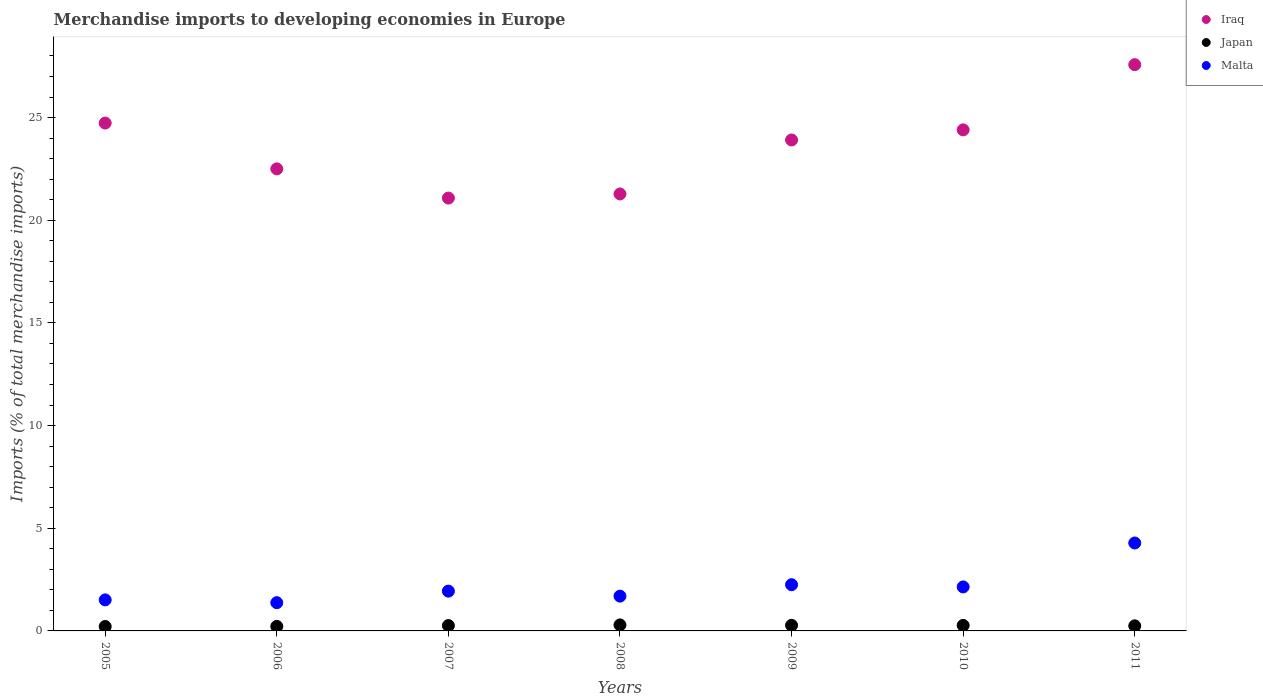How many different coloured dotlines are there?
Your answer should be compact. 3. What is the percentage total merchandise imports in Malta in 2009?
Your answer should be compact. 2.25. Across all years, what is the maximum percentage total merchandise imports in Malta?
Provide a short and direct response. 4.28. Across all years, what is the minimum percentage total merchandise imports in Malta?
Make the answer very short. 1.38. In which year was the percentage total merchandise imports in Japan maximum?
Your answer should be compact. 2008. In which year was the percentage total merchandise imports in Japan minimum?
Offer a very short reply. 2005. What is the total percentage total merchandise imports in Japan in the graph?
Your answer should be compact. 1.78. What is the difference between the percentage total merchandise imports in Malta in 2007 and that in 2011?
Provide a succinct answer. -2.34. What is the difference between the percentage total merchandise imports in Japan in 2006 and the percentage total merchandise imports in Iraq in 2009?
Keep it short and to the point. -23.69. What is the average percentage total merchandise imports in Japan per year?
Offer a terse response. 0.25. In the year 2011, what is the difference between the percentage total merchandise imports in Japan and percentage total merchandise imports in Iraq?
Keep it short and to the point. -27.33. What is the ratio of the percentage total merchandise imports in Iraq in 2006 to that in 2008?
Your answer should be compact. 1.06. What is the difference between the highest and the second highest percentage total merchandise imports in Malta?
Give a very brief answer. 2.03. What is the difference between the highest and the lowest percentage total merchandise imports in Japan?
Offer a terse response. 0.08. In how many years, is the percentage total merchandise imports in Malta greater than the average percentage total merchandise imports in Malta taken over all years?
Provide a short and direct response. 2. Is the percentage total merchandise imports in Iraq strictly greater than the percentage total merchandise imports in Japan over the years?
Offer a very short reply. Yes. Is the percentage total merchandise imports in Malta strictly less than the percentage total merchandise imports in Japan over the years?
Your response must be concise. No. How many years are there in the graph?
Ensure brevity in your answer.  7. What is the difference between two consecutive major ticks on the Y-axis?
Make the answer very short. 5. Are the values on the major ticks of Y-axis written in scientific E-notation?
Keep it short and to the point. No. Does the graph contain any zero values?
Your answer should be compact. No. Does the graph contain grids?
Keep it short and to the point. No. Where does the legend appear in the graph?
Your response must be concise. Top right. How many legend labels are there?
Provide a succinct answer. 3. How are the legend labels stacked?
Keep it short and to the point. Vertical. What is the title of the graph?
Provide a short and direct response. Merchandise imports to developing economies in Europe. Does "Latin America(developing only)" appear as one of the legend labels in the graph?
Offer a terse response. No. What is the label or title of the Y-axis?
Provide a succinct answer. Imports (% of total merchandise imports). What is the Imports (% of total merchandise imports) in Iraq in 2005?
Provide a succinct answer. 24.73. What is the Imports (% of total merchandise imports) of Japan in 2005?
Your answer should be very brief. 0.22. What is the Imports (% of total merchandise imports) in Malta in 2005?
Keep it short and to the point. 1.51. What is the Imports (% of total merchandise imports) of Iraq in 2006?
Keep it short and to the point. 22.5. What is the Imports (% of total merchandise imports) of Japan in 2006?
Ensure brevity in your answer.  0.22. What is the Imports (% of total merchandise imports) in Malta in 2006?
Ensure brevity in your answer.  1.38. What is the Imports (% of total merchandise imports) of Iraq in 2007?
Give a very brief answer. 21.08. What is the Imports (% of total merchandise imports) in Japan in 2007?
Give a very brief answer. 0.26. What is the Imports (% of total merchandise imports) in Malta in 2007?
Keep it short and to the point. 1.94. What is the Imports (% of total merchandise imports) in Iraq in 2008?
Ensure brevity in your answer.  21.28. What is the Imports (% of total merchandise imports) in Japan in 2008?
Offer a very short reply. 0.29. What is the Imports (% of total merchandise imports) in Malta in 2008?
Provide a succinct answer. 1.69. What is the Imports (% of total merchandise imports) in Iraq in 2009?
Make the answer very short. 23.91. What is the Imports (% of total merchandise imports) in Japan in 2009?
Your answer should be compact. 0.27. What is the Imports (% of total merchandise imports) in Malta in 2009?
Ensure brevity in your answer.  2.25. What is the Imports (% of total merchandise imports) in Iraq in 2010?
Give a very brief answer. 24.4. What is the Imports (% of total merchandise imports) in Japan in 2010?
Make the answer very short. 0.27. What is the Imports (% of total merchandise imports) in Malta in 2010?
Offer a very short reply. 2.14. What is the Imports (% of total merchandise imports) in Iraq in 2011?
Provide a short and direct response. 27.57. What is the Imports (% of total merchandise imports) in Japan in 2011?
Offer a very short reply. 0.25. What is the Imports (% of total merchandise imports) in Malta in 2011?
Offer a terse response. 4.28. Across all years, what is the maximum Imports (% of total merchandise imports) of Iraq?
Keep it short and to the point. 27.57. Across all years, what is the maximum Imports (% of total merchandise imports) in Japan?
Your response must be concise. 0.29. Across all years, what is the maximum Imports (% of total merchandise imports) of Malta?
Your response must be concise. 4.28. Across all years, what is the minimum Imports (% of total merchandise imports) of Iraq?
Ensure brevity in your answer.  21.08. Across all years, what is the minimum Imports (% of total merchandise imports) of Japan?
Give a very brief answer. 0.22. Across all years, what is the minimum Imports (% of total merchandise imports) in Malta?
Give a very brief answer. 1.38. What is the total Imports (% of total merchandise imports) of Iraq in the graph?
Your answer should be very brief. 165.47. What is the total Imports (% of total merchandise imports) of Japan in the graph?
Offer a terse response. 1.78. What is the total Imports (% of total merchandise imports) of Malta in the graph?
Your answer should be very brief. 15.19. What is the difference between the Imports (% of total merchandise imports) of Iraq in 2005 and that in 2006?
Make the answer very short. 2.23. What is the difference between the Imports (% of total merchandise imports) in Japan in 2005 and that in 2006?
Your answer should be compact. -0. What is the difference between the Imports (% of total merchandise imports) of Malta in 2005 and that in 2006?
Offer a very short reply. 0.14. What is the difference between the Imports (% of total merchandise imports) in Iraq in 2005 and that in 2007?
Your answer should be compact. 3.65. What is the difference between the Imports (% of total merchandise imports) in Japan in 2005 and that in 2007?
Your response must be concise. -0.05. What is the difference between the Imports (% of total merchandise imports) in Malta in 2005 and that in 2007?
Keep it short and to the point. -0.43. What is the difference between the Imports (% of total merchandise imports) of Iraq in 2005 and that in 2008?
Provide a succinct answer. 3.45. What is the difference between the Imports (% of total merchandise imports) of Japan in 2005 and that in 2008?
Provide a short and direct response. -0.08. What is the difference between the Imports (% of total merchandise imports) in Malta in 2005 and that in 2008?
Give a very brief answer. -0.18. What is the difference between the Imports (% of total merchandise imports) of Iraq in 2005 and that in 2009?
Your response must be concise. 0.82. What is the difference between the Imports (% of total merchandise imports) in Japan in 2005 and that in 2009?
Provide a short and direct response. -0.06. What is the difference between the Imports (% of total merchandise imports) of Malta in 2005 and that in 2009?
Make the answer very short. -0.74. What is the difference between the Imports (% of total merchandise imports) of Iraq in 2005 and that in 2010?
Your answer should be very brief. 0.33. What is the difference between the Imports (% of total merchandise imports) of Japan in 2005 and that in 2010?
Ensure brevity in your answer.  -0.05. What is the difference between the Imports (% of total merchandise imports) in Malta in 2005 and that in 2010?
Make the answer very short. -0.63. What is the difference between the Imports (% of total merchandise imports) of Iraq in 2005 and that in 2011?
Make the answer very short. -2.84. What is the difference between the Imports (% of total merchandise imports) in Japan in 2005 and that in 2011?
Give a very brief answer. -0.03. What is the difference between the Imports (% of total merchandise imports) in Malta in 2005 and that in 2011?
Your answer should be compact. -2.77. What is the difference between the Imports (% of total merchandise imports) in Iraq in 2006 and that in 2007?
Offer a terse response. 1.42. What is the difference between the Imports (% of total merchandise imports) of Japan in 2006 and that in 2007?
Keep it short and to the point. -0.04. What is the difference between the Imports (% of total merchandise imports) of Malta in 2006 and that in 2007?
Give a very brief answer. -0.56. What is the difference between the Imports (% of total merchandise imports) in Iraq in 2006 and that in 2008?
Provide a succinct answer. 1.22. What is the difference between the Imports (% of total merchandise imports) of Japan in 2006 and that in 2008?
Keep it short and to the point. -0.07. What is the difference between the Imports (% of total merchandise imports) of Malta in 2006 and that in 2008?
Your answer should be compact. -0.32. What is the difference between the Imports (% of total merchandise imports) of Iraq in 2006 and that in 2009?
Keep it short and to the point. -1.41. What is the difference between the Imports (% of total merchandise imports) in Japan in 2006 and that in 2009?
Offer a terse response. -0.05. What is the difference between the Imports (% of total merchandise imports) of Malta in 2006 and that in 2009?
Offer a terse response. -0.88. What is the difference between the Imports (% of total merchandise imports) in Iraq in 2006 and that in 2010?
Provide a succinct answer. -1.9. What is the difference between the Imports (% of total merchandise imports) in Japan in 2006 and that in 2010?
Your answer should be compact. -0.05. What is the difference between the Imports (% of total merchandise imports) of Malta in 2006 and that in 2010?
Give a very brief answer. -0.77. What is the difference between the Imports (% of total merchandise imports) in Iraq in 2006 and that in 2011?
Provide a succinct answer. -5.07. What is the difference between the Imports (% of total merchandise imports) of Japan in 2006 and that in 2011?
Keep it short and to the point. -0.03. What is the difference between the Imports (% of total merchandise imports) of Malta in 2006 and that in 2011?
Your response must be concise. -2.91. What is the difference between the Imports (% of total merchandise imports) in Iraq in 2007 and that in 2008?
Your answer should be compact. -0.2. What is the difference between the Imports (% of total merchandise imports) of Japan in 2007 and that in 2008?
Make the answer very short. -0.03. What is the difference between the Imports (% of total merchandise imports) of Malta in 2007 and that in 2008?
Provide a succinct answer. 0.24. What is the difference between the Imports (% of total merchandise imports) in Iraq in 2007 and that in 2009?
Make the answer very short. -2.83. What is the difference between the Imports (% of total merchandise imports) of Japan in 2007 and that in 2009?
Give a very brief answer. -0.01. What is the difference between the Imports (% of total merchandise imports) in Malta in 2007 and that in 2009?
Make the answer very short. -0.31. What is the difference between the Imports (% of total merchandise imports) in Iraq in 2007 and that in 2010?
Offer a terse response. -3.32. What is the difference between the Imports (% of total merchandise imports) in Japan in 2007 and that in 2010?
Ensure brevity in your answer.  -0.01. What is the difference between the Imports (% of total merchandise imports) in Malta in 2007 and that in 2010?
Offer a very short reply. -0.21. What is the difference between the Imports (% of total merchandise imports) of Iraq in 2007 and that in 2011?
Give a very brief answer. -6.5. What is the difference between the Imports (% of total merchandise imports) of Japan in 2007 and that in 2011?
Give a very brief answer. 0.01. What is the difference between the Imports (% of total merchandise imports) of Malta in 2007 and that in 2011?
Keep it short and to the point. -2.34. What is the difference between the Imports (% of total merchandise imports) of Iraq in 2008 and that in 2009?
Provide a succinct answer. -2.63. What is the difference between the Imports (% of total merchandise imports) of Japan in 2008 and that in 2009?
Ensure brevity in your answer.  0.02. What is the difference between the Imports (% of total merchandise imports) in Malta in 2008 and that in 2009?
Keep it short and to the point. -0.56. What is the difference between the Imports (% of total merchandise imports) of Iraq in 2008 and that in 2010?
Your response must be concise. -3.12. What is the difference between the Imports (% of total merchandise imports) of Japan in 2008 and that in 2010?
Keep it short and to the point. 0.03. What is the difference between the Imports (% of total merchandise imports) in Malta in 2008 and that in 2010?
Your answer should be very brief. -0.45. What is the difference between the Imports (% of total merchandise imports) in Iraq in 2008 and that in 2011?
Offer a terse response. -6.3. What is the difference between the Imports (% of total merchandise imports) in Japan in 2008 and that in 2011?
Give a very brief answer. 0.04. What is the difference between the Imports (% of total merchandise imports) of Malta in 2008 and that in 2011?
Give a very brief answer. -2.59. What is the difference between the Imports (% of total merchandise imports) in Iraq in 2009 and that in 2010?
Give a very brief answer. -0.49. What is the difference between the Imports (% of total merchandise imports) of Japan in 2009 and that in 2010?
Provide a succinct answer. 0.01. What is the difference between the Imports (% of total merchandise imports) in Malta in 2009 and that in 2010?
Your answer should be very brief. 0.11. What is the difference between the Imports (% of total merchandise imports) of Iraq in 2009 and that in 2011?
Offer a very short reply. -3.67. What is the difference between the Imports (% of total merchandise imports) in Japan in 2009 and that in 2011?
Your answer should be compact. 0.02. What is the difference between the Imports (% of total merchandise imports) in Malta in 2009 and that in 2011?
Make the answer very short. -2.03. What is the difference between the Imports (% of total merchandise imports) in Iraq in 2010 and that in 2011?
Provide a short and direct response. -3.17. What is the difference between the Imports (% of total merchandise imports) in Japan in 2010 and that in 2011?
Your response must be concise. 0.02. What is the difference between the Imports (% of total merchandise imports) in Malta in 2010 and that in 2011?
Keep it short and to the point. -2.14. What is the difference between the Imports (% of total merchandise imports) in Iraq in 2005 and the Imports (% of total merchandise imports) in Japan in 2006?
Provide a succinct answer. 24.51. What is the difference between the Imports (% of total merchandise imports) of Iraq in 2005 and the Imports (% of total merchandise imports) of Malta in 2006?
Your answer should be compact. 23.36. What is the difference between the Imports (% of total merchandise imports) of Japan in 2005 and the Imports (% of total merchandise imports) of Malta in 2006?
Provide a short and direct response. -1.16. What is the difference between the Imports (% of total merchandise imports) of Iraq in 2005 and the Imports (% of total merchandise imports) of Japan in 2007?
Give a very brief answer. 24.47. What is the difference between the Imports (% of total merchandise imports) in Iraq in 2005 and the Imports (% of total merchandise imports) in Malta in 2007?
Offer a terse response. 22.79. What is the difference between the Imports (% of total merchandise imports) in Japan in 2005 and the Imports (% of total merchandise imports) in Malta in 2007?
Your answer should be very brief. -1.72. What is the difference between the Imports (% of total merchandise imports) of Iraq in 2005 and the Imports (% of total merchandise imports) of Japan in 2008?
Offer a terse response. 24.44. What is the difference between the Imports (% of total merchandise imports) of Iraq in 2005 and the Imports (% of total merchandise imports) of Malta in 2008?
Keep it short and to the point. 23.04. What is the difference between the Imports (% of total merchandise imports) of Japan in 2005 and the Imports (% of total merchandise imports) of Malta in 2008?
Make the answer very short. -1.48. What is the difference between the Imports (% of total merchandise imports) in Iraq in 2005 and the Imports (% of total merchandise imports) in Japan in 2009?
Your answer should be very brief. 24.46. What is the difference between the Imports (% of total merchandise imports) in Iraq in 2005 and the Imports (% of total merchandise imports) in Malta in 2009?
Your response must be concise. 22.48. What is the difference between the Imports (% of total merchandise imports) in Japan in 2005 and the Imports (% of total merchandise imports) in Malta in 2009?
Give a very brief answer. -2.04. What is the difference between the Imports (% of total merchandise imports) in Iraq in 2005 and the Imports (% of total merchandise imports) in Japan in 2010?
Offer a very short reply. 24.46. What is the difference between the Imports (% of total merchandise imports) of Iraq in 2005 and the Imports (% of total merchandise imports) of Malta in 2010?
Your answer should be very brief. 22.59. What is the difference between the Imports (% of total merchandise imports) in Japan in 2005 and the Imports (% of total merchandise imports) in Malta in 2010?
Provide a succinct answer. -1.93. What is the difference between the Imports (% of total merchandise imports) in Iraq in 2005 and the Imports (% of total merchandise imports) in Japan in 2011?
Make the answer very short. 24.48. What is the difference between the Imports (% of total merchandise imports) in Iraq in 2005 and the Imports (% of total merchandise imports) in Malta in 2011?
Provide a short and direct response. 20.45. What is the difference between the Imports (% of total merchandise imports) of Japan in 2005 and the Imports (% of total merchandise imports) of Malta in 2011?
Ensure brevity in your answer.  -4.07. What is the difference between the Imports (% of total merchandise imports) in Iraq in 2006 and the Imports (% of total merchandise imports) in Japan in 2007?
Your response must be concise. 22.24. What is the difference between the Imports (% of total merchandise imports) of Iraq in 2006 and the Imports (% of total merchandise imports) of Malta in 2007?
Your answer should be compact. 20.56. What is the difference between the Imports (% of total merchandise imports) in Japan in 2006 and the Imports (% of total merchandise imports) in Malta in 2007?
Your answer should be compact. -1.72. What is the difference between the Imports (% of total merchandise imports) in Iraq in 2006 and the Imports (% of total merchandise imports) in Japan in 2008?
Keep it short and to the point. 22.21. What is the difference between the Imports (% of total merchandise imports) of Iraq in 2006 and the Imports (% of total merchandise imports) of Malta in 2008?
Keep it short and to the point. 20.81. What is the difference between the Imports (% of total merchandise imports) of Japan in 2006 and the Imports (% of total merchandise imports) of Malta in 2008?
Your answer should be very brief. -1.47. What is the difference between the Imports (% of total merchandise imports) of Iraq in 2006 and the Imports (% of total merchandise imports) of Japan in 2009?
Provide a succinct answer. 22.23. What is the difference between the Imports (% of total merchandise imports) in Iraq in 2006 and the Imports (% of total merchandise imports) in Malta in 2009?
Provide a succinct answer. 20.25. What is the difference between the Imports (% of total merchandise imports) of Japan in 2006 and the Imports (% of total merchandise imports) of Malta in 2009?
Provide a succinct answer. -2.03. What is the difference between the Imports (% of total merchandise imports) of Iraq in 2006 and the Imports (% of total merchandise imports) of Japan in 2010?
Your answer should be very brief. 22.23. What is the difference between the Imports (% of total merchandise imports) in Iraq in 2006 and the Imports (% of total merchandise imports) in Malta in 2010?
Make the answer very short. 20.36. What is the difference between the Imports (% of total merchandise imports) of Japan in 2006 and the Imports (% of total merchandise imports) of Malta in 2010?
Provide a succinct answer. -1.92. What is the difference between the Imports (% of total merchandise imports) of Iraq in 2006 and the Imports (% of total merchandise imports) of Japan in 2011?
Offer a very short reply. 22.25. What is the difference between the Imports (% of total merchandise imports) of Iraq in 2006 and the Imports (% of total merchandise imports) of Malta in 2011?
Provide a short and direct response. 18.22. What is the difference between the Imports (% of total merchandise imports) of Japan in 2006 and the Imports (% of total merchandise imports) of Malta in 2011?
Make the answer very short. -4.06. What is the difference between the Imports (% of total merchandise imports) in Iraq in 2007 and the Imports (% of total merchandise imports) in Japan in 2008?
Give a very brief answer. 20.79. What is the difference between the Imports (% of total merchandise imports) of Iraq in 2007 and the Imports (% of total merchandise imports) of Malta in 2008?
Offer a very short reply. 19.38. What is the difference between the Imports (% of total merchandise imports) of Japan in 2007 and the Imports (% of total merchandise imports) of Malta in 2008?
Ensure brevity in your answer.  -1.43. What is the difference between the Imports (% of total merchandise imports) in Iraq in 2007 and the Imports (% of total merchandise imports) in Japan in 2009?
Your answer should be very brief. 20.81. What is the difference between the Imports (% of total merchandise imports) in Iraq in 2007 and the Imports (% of total merchandise imports) in Malta in 2009?
Make the answer very short. 18.83. What is the difference between the Imports (% of total merchandise imports) of Japan in 2007 and the Imports (% of total merchandise imports) of Malta in 2009?
Offer a terse response. -1.99. What is the difference between the Imports (% of total merchandise imports) in Iraq in 2007 and the Imports (% of total merchandise imports) in Japan in 2010?
Provide a short and direct response. 20.81. What is the difference between the Imports (% of total merchandise imports) of Iraq in 2007 and the Imports (% of total merchandise imports) of Malta in 2010?
Ensure brevity in your answer.  18.94. What is the difference between the Imports (% of total merchandise imports) of Japan in 2007 and the Imports (% of total merchandise imports) of Malta in 2010?
Give a very brief answer. -1.88. What is the difference between the Imports (% of total merchandise imports) of Iraq in 2007 and the Imports (% of total merchandise imports) of Japan in 2011?
Provide a succinct answer. 20.83. What is the difference between the Imports (% of total merchandise imports) of Iraq in 2007 and the Imports (% of total merchandise imports) of Malta in 2011?
Your response must be concise. 16.8. What is the difference between the Imports (% of total merchandise imports) of Japan in 2007 and the Imports (% of total merchandise imports) of Malta in 2011?
Give a very brief answer. -4.02. What is the difference between the Imports (% of total merchandise imports) of Iraq in 2008 and the Imports (% of total merchandise imports) of Japan in 2009?
Ensure brevity in your answer.  21.01. What is the difference between the Imports (% of total merchandise imports) in Iraq in 2008 and the Imports (% of total merchandise imports) in Malta in 2009?
Provide a short and direct response. 19.03. What is the difference between the Imports (% of total merchandise imports) of Japan in 2008 and the Imports (% of total merchandise imports) of Malta in 2009?
Make the answer very short. -1.96. What is the difference between the Imports (% of total merchandise imports) of Iraq in 2008 and the Imports (% of total merchandise imports) of Japan in 2010?
Your answer should be compact. 21.01. What is the difference between the Imports (% of total merchandise imports) in Iraq in 2008 and the Imports (% of total merchandise imports) in Malta in 2010?
Make the answer very short. 19.14. What is the difference between the Imports (% of total merchandise imports) of Japan in 2008 and the Imports (% of total merchandise imports) of Malta in 2010?
Ensure brevity in your answer.  -1.85. What is the difference between the Imports (% of total merchandise imports) in Iraq in 2008 and the Imports (% of total merchandise imports) in Japan in 2011?
Provide a short and direct response. 21.03. What is the difference between the Imports (% of total merchandise imports) of Iraq in 2008 and the Imports (% of total merchandise imports) of Malta in 2011?
Your response must be concise. 17. What is the difference between the Imports (% of total merchandise imports) of Japan in 2008 and the Imports (% of total merchandise imports) of Malta in 2011?
Offer a terse response. -3.99. What is the difference between the Imports (% of total merchandise imports) in Iraq in 2009 and the Imports (% of total merchandise imports) in Japan in 2010?
Your answer should be very brief. 23.64. What is the difference between the Imports (% of total merchandise imports) in Iraq in 2009 and the Imports (% of total merchandise imports) in Malta in 2010?
Your answer should be very brief. 21.77. What is the difference between the Imports (% of total merchandise imports) in Japan in 2009 and the Imports (% of total merchandise imports) in Malta in 2010?
Your answer should be compact. -1.87. What is the difference between the Imports (% of total merchandise imports) in Iraq in 2009 and the Imports (% of total merchandise imports) in Japan in 2011?
Ensure brevity in your answer.  23.66. What is the difference between the Imports (% of total merchandise imports) in Iraq in 2009 and the Imports (% of total merchandise imports) in Malta in 2011?
Provide a short and direct response. 19.63. What is the difference between the Imports (% of total merchandise imports) in Japan in 2009 and the Imports (% of total merchandise imports) in Malta in 2011?
Make the answer very short. -4.01. What is the difference between the Imports (% of total merchandise imports) in Iraq in 2010 and the Imports (% of total merchandise imports) in Japan in 2011?
Your response must be concise. 24.15. What is the difference between the Imports (% of total merchandise imports) in Iraq in 2010 and the Imports (% of total merchandise imports) in Malta in 2011?
Your response must be concise. 20.12. What is the difference between the Imports (% of total merchandise imports) in Japan in 2010 and the Imports (% of total merchandise imports) in Malta in 2011?
Your answer should be very brief. -4.01. What is the average Imports (% of total merchandise imports) in Iraq per year?
Offer a terse response. 23.64. What is the average Imports (% of total merchandise imports) of Japan per year?
Offer a terse response. 0.25. What is the average Imports (% of total merchandise imports) in Malta per year?
Give a very brief answer. 2.17. In the year 2005, what is the difference between the Imports (% of total merchandise imports) of Iraq and Imports (% of total merchandise imports) of Japan?
Offer a very short reply. 24.52. In the year 2005, what is the difference between the Imports (% of total merchandise imports) of Iraq and Imports (% of total merchandise imports) of Malta?
Make the answer very short. 23.22. In the year 2005, what is the difference between the Imports (% of total merchandise imports) of Japan and Imports (% of total merchandise imports) of Malta?
Your answer should be very brief. -1.3. In the year 2006, what is the difference between the Imports (% of total merchandise imports) in Iraq and Imports (% of total merchandise imports) in Japan?
Ensure brevity in your answer.  22.28. In the year 2006, what is the difference between the Imports (% of total merchandise imports) in Iraq and Imports (% of total merchandise imports) in Malta?
Offer a very short reply. 21.13. In the year 2006, what is the difference between the Imports (% of total merchandise imports) in Japan and Imports (% of total merchandise imports) in Malta?
Your answer should be very brief. -1.16. In the year 2007, what is the difference between the Imports (% of total merchandise imports) in Iraq and Imports (% of total merchandise imports) in Japan?
Provide a succinct answer. 20.82. In the year 2007, what is the difference between the Imports (% of total merchandise imports) in Iraq and Imports (% of total merchandise imports) in Malta?
Offer a very short reply. 19.14. In the year 2007, what is the difference between the Imports (% of total merchandise imports) of Japan and Imports (% of total merchandise imports) of Malta?
Give a very brief answer. -1.68. In the year 2008, what is the difference between the Imports (% of total merchandise imports) of Iraq and Imports (% of total merchandise imports) of Japan?
Offer a terse response. 20.99. In the year 2008, what is the difference between the Imports (% of total merchandise imports) of Iraq and Imports (% of total merchandise imports) of Malta?
Keep it short and to the point. 19.59. In the year 2008, what is the difference between the Imports (% of total merchandise imports) in Japan and Imports (% of total merchandise imports) in Malta?
Your answer should be compact. -1.4. In the year 2009, what is the difference between the Imports (% of total merchandise imports) of Iraq and Imports (% of total merchandise imports) of Japan?
Make the answer very short. 23.64. In the year 2009, what is the difference between the Imports (% of total merchandise imports) of Iraq and Imports (% of total merchandise imports) of Malta?
Make the answer very short. 21.66. In the year 2009, what is the difference between the Imports (% of total merchandise imports) in Japan and Imports (% of total merchandise imports) in Malta?
Give a very brief answer. -1.98. In the year 2010, what is the difference between the Imports (% of total merchandise imports) of Iraq and Imports (% of total merchandise imports) of Japan?
Offer a terse response. 24.13. In the year 2010, what is the difference between the Imports (% of total merchandise imports) in Iraq and Imports (% of total merchandise imports) in Malta?
Ensure brevity in your answer.  22.26. In the year 2010, what is the difference between the Imports (% of total merchandise imports) in Japan and Imports (% of total merchandise imports) in Malta?
Provide a succinct answer. -1.88. In the year 2011, what is the difference between the Imports (% of total merchandise imports) of Iraq and Imports (% of total merchandise imports) of Japan?
Your answer should be very brief. 27.33. In the year 2011, what is the difference between the Imports (% of total merchandise imports) of Iraq and Imports (% of total merchandise imports) of Malta?
Provide a short and direct response. 23.29. In the year 2011, what is the difference between the Imports (% of total merchandise imports) in Japan and Imports (% of total merchandise imports) in Malta?
Your answer should be very brief. -4.03. What is the ratio of the Imports (% of total merchandise imports) in Iraq in 2005 to that in 2006?
Your response must be concise. 1.1. What is the ratio of the Imports (% of total merchandise imports) in Japan in 2005 to that in 2006?
Keep it short and to the point. 0.98. What is the ratio of the Imports (% of total merchandise imports) of Malta in 2005 to that in 2006?
Give a very brief answer. 1.1. What is the ratio of the Imports (% of total merchandise imports) of Iraq in 2005 to that in 2007?
Your response must be concise. 1.17. What is the ratio of the Imports (% of total merchandise imports) of Japan in 2005 to that in 2007?
Keep it short and to the point. 0.82. What is the ratio of the Imports (% of total merchandise imports) of Malta in 2005 to that in 2007?
Your response must be concise. 0.78. What is the ratio of the Imports (% of total merchandise imports) of Iraq in 2005 to that in 2008?
Provide a succinct answer. 1.16. What is the ratio of the Imports (% of total merchandise imports) of Japan in 2005 to that in 2008?
Offer a terse response. 0.74. What is the ratio of the Imports (% of total merchandise imports) of Malta in 2005 to that in 2008?
Your answer should be very brief. 0.89. What is the ratio of the Imports (% of total merchandise imports) of Iraq in 2005 to that in 2009?
Keep it short and to the point. 1.03. What is the ratio of the Imports (% of total merchandise imports) of Japan in 2005 to that in 2009?
Your response must be concise. 0.79. What is the ratio of the Imports (% of total merchandise imports) of Malta in 2005 to that in 2009?
Make the answer very short. 0.67. What is the ratio of the Imports (% of total merchandise imports) in Iraq in 2005 to that in 2010?
Keep it short and to the point. 1.01. What is the ratio of the Imports (% of total merchandise imports) of Japan in 2005 to that in 2010?
Ensure brevity in your answer.  0.81. What is the ratio of the Imports (% of total merchandise imports) in Malta in 2005 to that in 2010?
Provide a succinct answer. 0.71. What is the ratio of the Imports (% of total merchandise imports) of Iraq in 2005 to that in 2011?
Your answer should be compact. 0.9. What is the ratio of the Imports (% of total merchandise imports) of Japan in 2005 to that in 2011?
Keep it short and to the point. 0.87. What is the ratio of the Imports (% of total merchandise imports) in Malta in 2005 to that in 2011?
Keep it short and to the point. 0.35. What is the ratio of the Imports (% of total merchandise imports) in Iraq in 2006 to that in 2007?
Ensure brevity in your answer.  1.07. What is the ratio of the Imports (% of total merchandise imports) in Japan in 2006 to that in 2007?
Provide a succinct answer. 0.84. What is the ratio of the Imports (% of total merchandise imports) of Malta in 2006 to that in 2007?
Offer a terse response. 0.71. What is the ratio of the Imports (% of total merchandise imports) in Iraq in 2006 to that in 2008?
Your response must be concise. 1.06. What is the ratio of the Imports (% of total merchandise imports) of Japan in 2006 to that in 2008?
Ensure brevity in your answer.  0.75. What is the ratio of the Imports (% of total merchandise imports) of Malta in 2006 to that in 2008?
Your response must be concise. 0.81. What is the ratio of the Imports (% of total merchandise imports) of Iraq in 2006 to that in 2009?
Keep it short and to the point. 0.94. What is the ratio of the Imports (% of total merchandise imports) in Japan in 2006 to that in 2009?
Ensure brevity in your answer.  0.81. What is the ratio of the Imports (% of total merchandise imports) in Malta in 2006 to that in 2009?
Keep it short and to the point. 0.61. What is the ratio of the Imports (% of total merchandise imports) in Iraq in 2006 to that in 2010?
Provide a succinct answer. 0.92. What is the ratio of the Imports (% of total merchandise imports) of Japan in 2006 to that in 2010?
Make the answer very short. 0.82. What is the ratio of the Imports (% of total merchandise imports) in Malta in 2006 to that in 2010?
Offer a very short reply. 0.64. What is the ratio of the Imports (% of total merchandise imports) in Iraq in 2006 to that in 2011?
Your answer should be very brief. 0.82. What is the ratio of the Imports (% of total merchandise imports) of Japan in 2006 to that in 2011?
Offer a very short reply. 0.89. What is the ratio of the Imports (% of total merchandise imports) of Malta in 2006 to that in 2011?
Your answer should be compact. 0.32. What is the ratio of the Imports (% of total merchandise imports) of Iraq in 2007 to that in 2008?
Ensure brevity in your answer.  0.99. What is the ratio of the Imports (% of total merchandise imports) in Japan in 2007 to that in 2008?
Keep it short and to the point. 0.89. What is the ratio of the Imports (% of total merchandise imports) in Malta in 2007 to that in 2008?
Your answer should be very brief. 1.14. What is the ratio of the Imports (% of total merchandise imports) of Iraq in 2007 to that in 2009?
Ensure brevity in your answer.  0.88. What is the ratio of the Imports (% of total merchandise imports) of Japan in 2007 to that in 2009?
Your answer should be compact. 0.96. What is the ratio of the Imports (% of total merchandise imports) of Malta in 2007 to that in 2009?
Your answer should be compact. 0.86. What is the ratio of the Imports (% of total merchandise imports) in Iraq in 2007 to that in 2010?
Your answer should be very brief. 0.86. What is the ratio of the Imports (% of total merchandise imports) of Japan in 2007 to that in 2010?
Ensure brevity in your answer.  0.98. What is the ratio of the Imports (% of total merchandise imports) in Malta in 2007 to that in 2010?
Offer a very short reply. 0.9. What is the ratio of the Imports (% of total merchandise imports) of Iraq in 2007 to that in 2011?
Provide a short and direct response. 0.76. What is the ratio of the Imports (% of total merchandise imports) of Japan in 2007 to that in 2011?
Keep it short and to the point. 1.05. What is the ratio of the Imports (% of total merchandise imports) of Malta in 2007 to that in 2011?
Provide a succinct answer. 0.45. What is the ratio of the Imports (% of total merchandise imports) in Iraq in 2008 to that in 2009?
Provide a short and direct response. 0.89. What is the ratio of the Imports (% of total merchandise imports) in Japan in 2008 to that in 2009?
Your response must be concise. 1.07. What is the ratio of the Imports (% of total merchandise imports) of Malta in 2008 to that in 2009?
Give a very brief answer. 0.75. What is the ratio of the Imports (% of total merchandise imports) in Iraq in 2008 to that in 2010?
Your answer should be compact. 0.87. What is the ratio of the Imports (% of total merchandise imports) of Japan in 2008 to that in 2010?
Make the answer very short. 1.09. What is the ratio of the Imports (% of total merchandise imports) of Malta in 2008 to that in 2010?
Your response must be concise. 0.79. What is the ratio of the Imports (% of total merchandise imports) of Iraq in 2008 to that in 2011?
Ensure brevity in your answer.  0.77. What is the ratio of the Imports (% of total merchandise imports) of Japan in 2008 to that in 2011?
Your response must be concise. 1.18. What is the ratio of the Imports (% of total merchandise imports) in Malta in 2008 to that in 2011?
Provide a succinct answer. 0.4. What is the ratio of the Imports (% of total merchandise imports) in Iraq in 2009 to that in 2010?
Your answer should be very brief. 0.98. What is the ratio of the Imports (% of total merchandise imports) in Japan in 2009 to that in 2010?
Offer a very short reply. 1.02. What is the ratio of the Imports (% of total merchandise imports) in Malta in 2009 to that in 2010?
Offer a terse response. 1.05. What is the ratio of the Imports (% of total merchandise imports) in Iraq in 2009 to that in 2011?
Your answer should be compact. 0.87. What is the ratio of the Imports (% of total merchandise imports) of Japan in 2009 to that in 2011?
Make the answer very short. 1.1. What is the ratio of the Imports (% of total merchandise imports) of Malta in 2009 to that in 2011?
Offer a terse response. 0.53. What is the ratio of the Imports (% of total merchandise imports) of Iraq in 2010 to that in 2011?
Offer a very short reply. 0.88. What is the ratio of the Imports (% of total merchandise imports) in Japan in 2010 to that in 2011?
Provide a short and direct response. 1.08. What is the ratio of the Imports (% of total merchandise imports) of Malta in 2010 to that in 2011?
Provide a short and direct response. 0.5. What is the difference between the highest and the second highest Imports (% of total merchandise imports) in Iraq?
Offer a terse response. 2.84. What is the difference between the highest and the second highest Imports (% of total merchandise imports) in Japan?
Provide a short and direct response. 0.02. What is the difference between the highest and the second highest Imports (% of total merchandise imports) in Malta?
Your response must be concise. 2.03. What is the difference between the highest and the lowest Imports (% of total merchandise imports) in Iraq?
Offer a terse response. 6.5. What is the difference between the highest and the lowest Imports (% of total merchandise imports) in Japan?
Ensure brevity in your answer.  0.08. What is the difference between the highest and the lowest Imports (% of total merchandise imports) in Malta?
Your response must be concise. 2.91. 